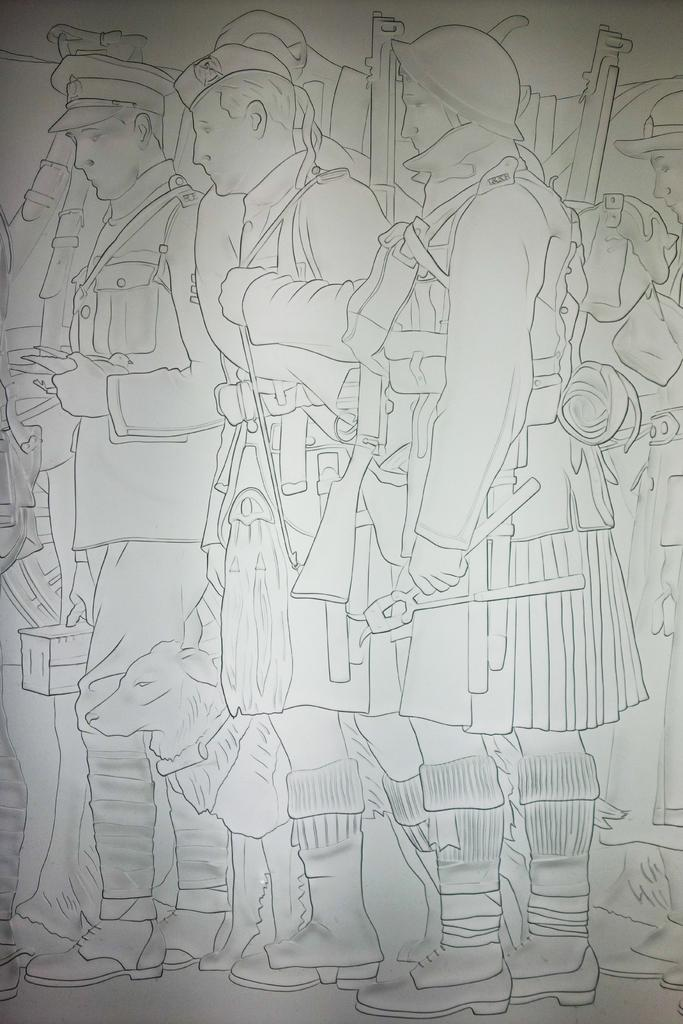What is depicted in the sketch in the image? There is a sketch of a dog in the image. Who else is present in the image besides the dog? There are people in the image. What are the people holding in the image? The people are holding something, but the specific object is not mentioned in the facts. What color is the background of the image? The background of the image is white. Can you hear the yak whistling in the image? There is no yak or whistling present in the image; it features a sketch of a dog and people holding something. 